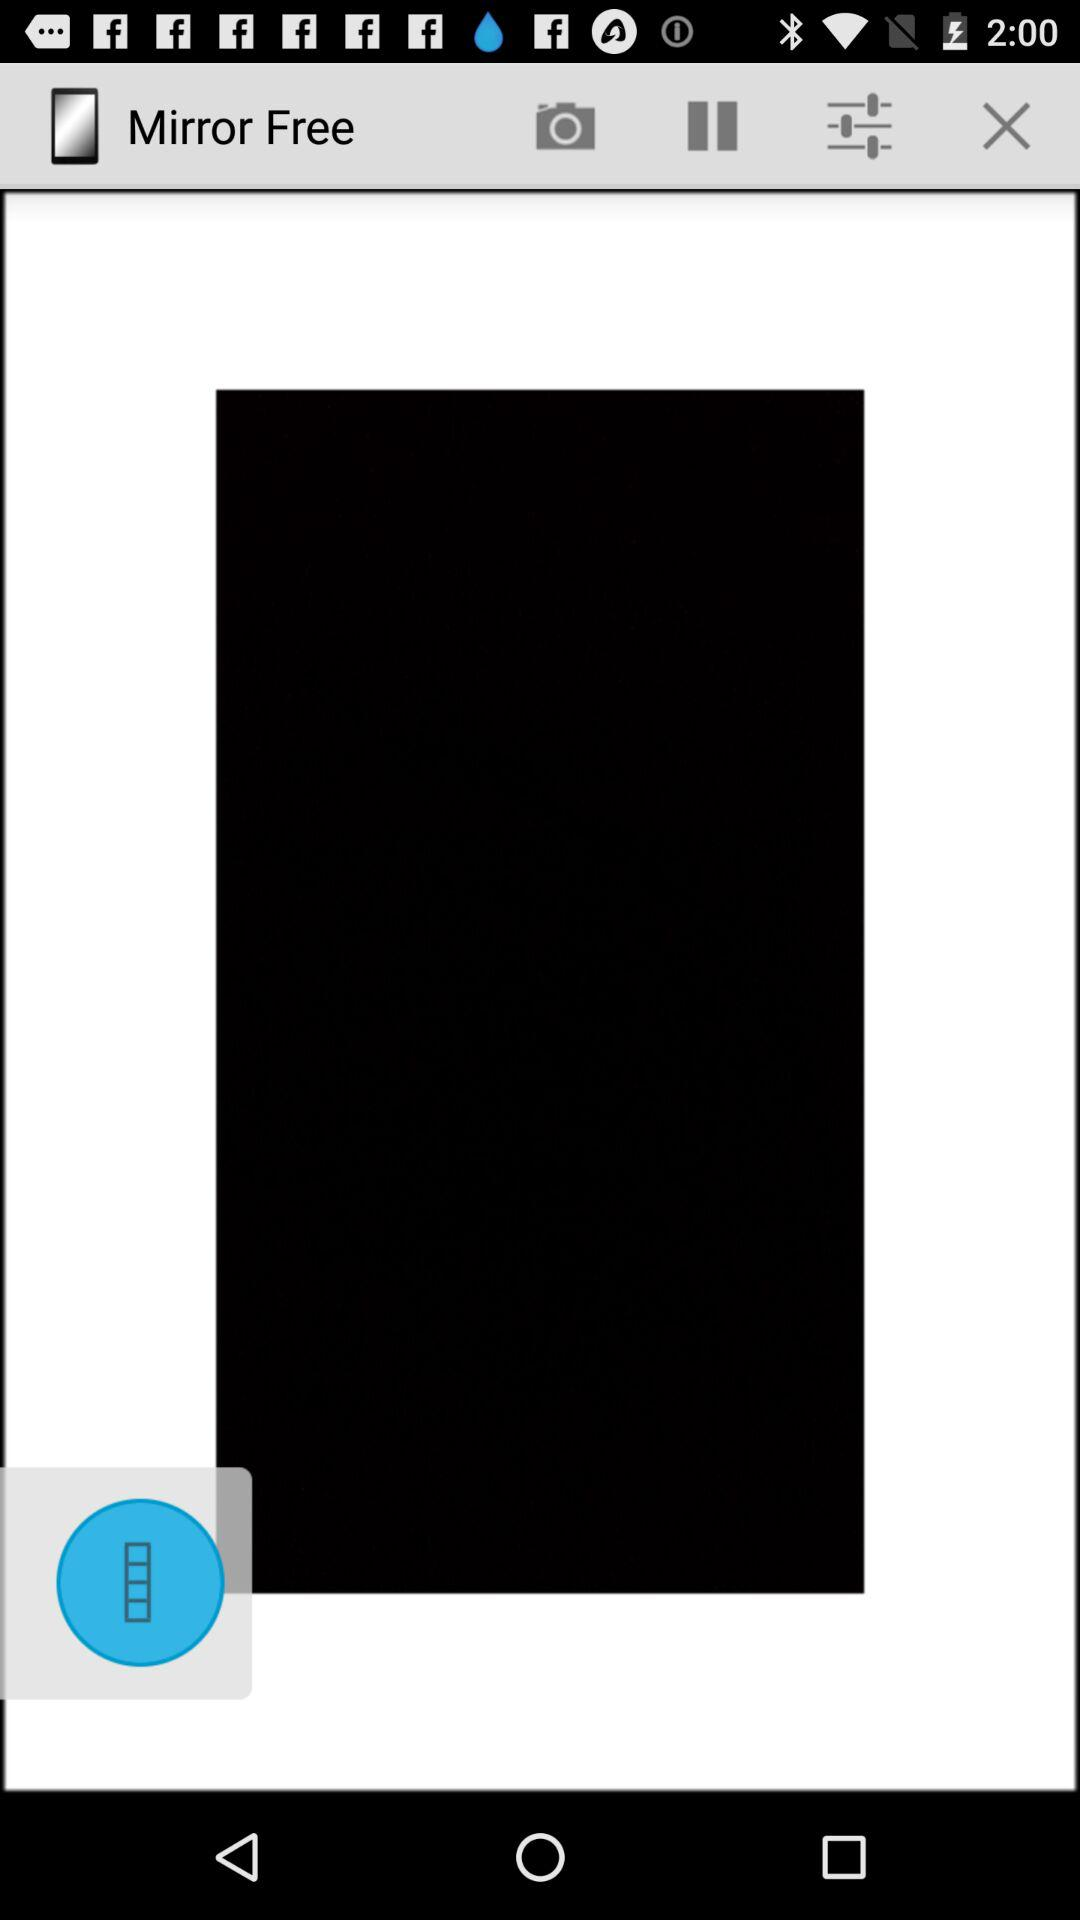Which filters were chosen?
When the provided information is insufficient, respond with <no answer>. <no answer> 